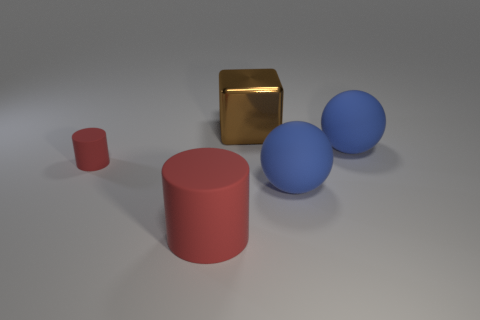What number of other objects are the same size as the brown thing?
Your response must be concise. 3. There is a cylinder that is in front of the large blue sphere in front of the red rubber cylinder that is left of the big red rubber thing; what is its material?
Your answer should be very brief. Rubber. Is the tiny red thing made of the same material as the big thing on the left side of the block?
Offer a terse response. Yes. Are there fewer large blue matte spheres that are in front of the big red thing than large blue things right of the small thing?
Your answer should be very brief. Yes. How many red objects are made of the same material as the big brown cube?
Keep it short and to the point. 0. Are there any blocks that are in front of the rubber thing that is to the left of the large object left of the large brown block?
Keep it short and to the point. No. How many blocks are either large shiny objects or large rubber things?
Provide a succinct answer. 1. There is a shiny object; does it have the same shape as the big matte thing that is to the left of the big brown shiny object?
Your response must be concise. No. Is the number of big cubes left of the metallic cube less than the number of objects?
Provide a succinct answer. Yes. There is a brown block; are there any red cylinders behind it?
Give a very brief answer. No. 